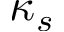<formula> <loc_0><loc_0><loc_500><loc_500>\kappa _ { s }</formula> 